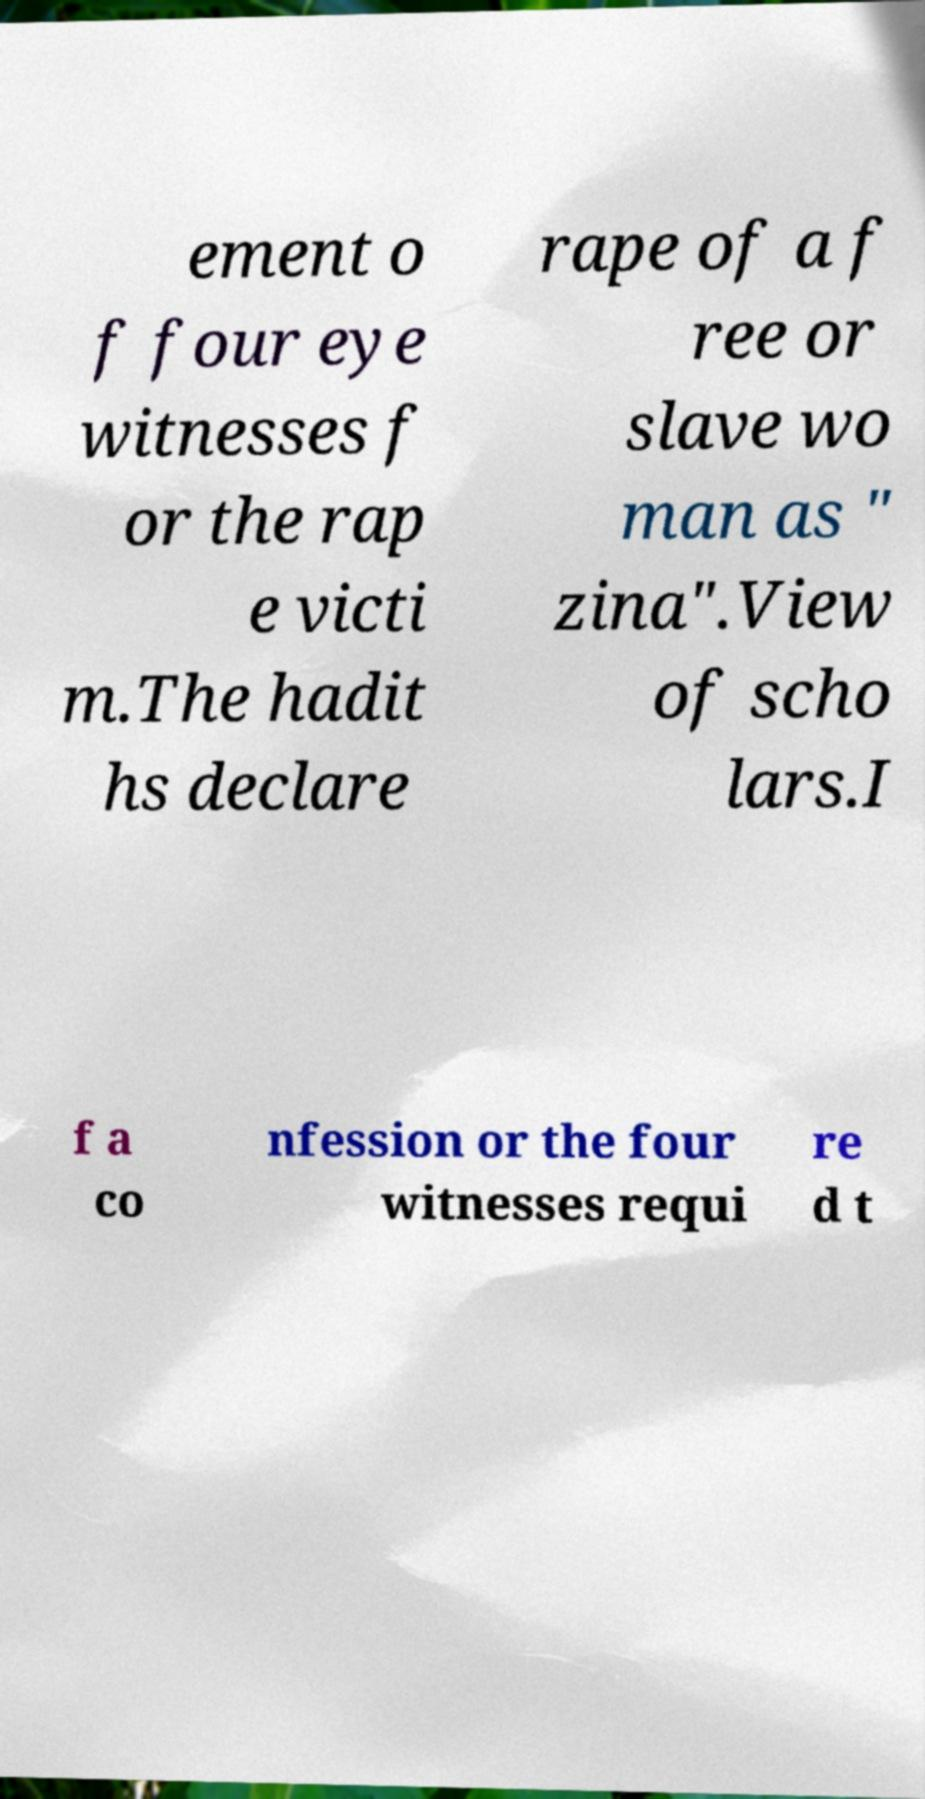Please identify and transcribe the text found in this image. ement o f four eye witnesses f or the rap e victi m.The hadit hs declare rape of a f ree or slave wo man as " zina".View of scho lars.I f a co nfession or the four witnesses requi re d t 